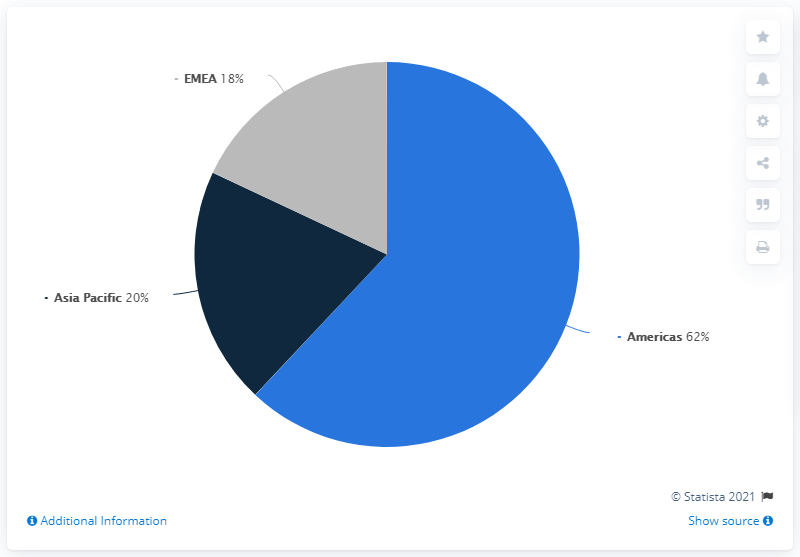Indicate a few pertinent items in this graphic. In 2020, 20% of Crocs' total sales were generated from the Asia Pacific region. The color that represents the Asia-Pacific region is dark blue. The average of America and EMEA (Europe, Middle East, and Africa) is approximately 40. 